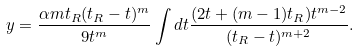Convert formula to latex. <formula><loc_0><loc_0><loc_500><loc_500>y = \frac { \alpha m t _ { R } ( t _ { R } - t ) ^ { m } } { 9 t ^ { m } } \int d t \frac { ( 2 t + ( m - 1 ) t _ { R } ) t ^ { m - 2 } } { ( t _ { R } - t ) ^ { m + 2 } } .</formula> 